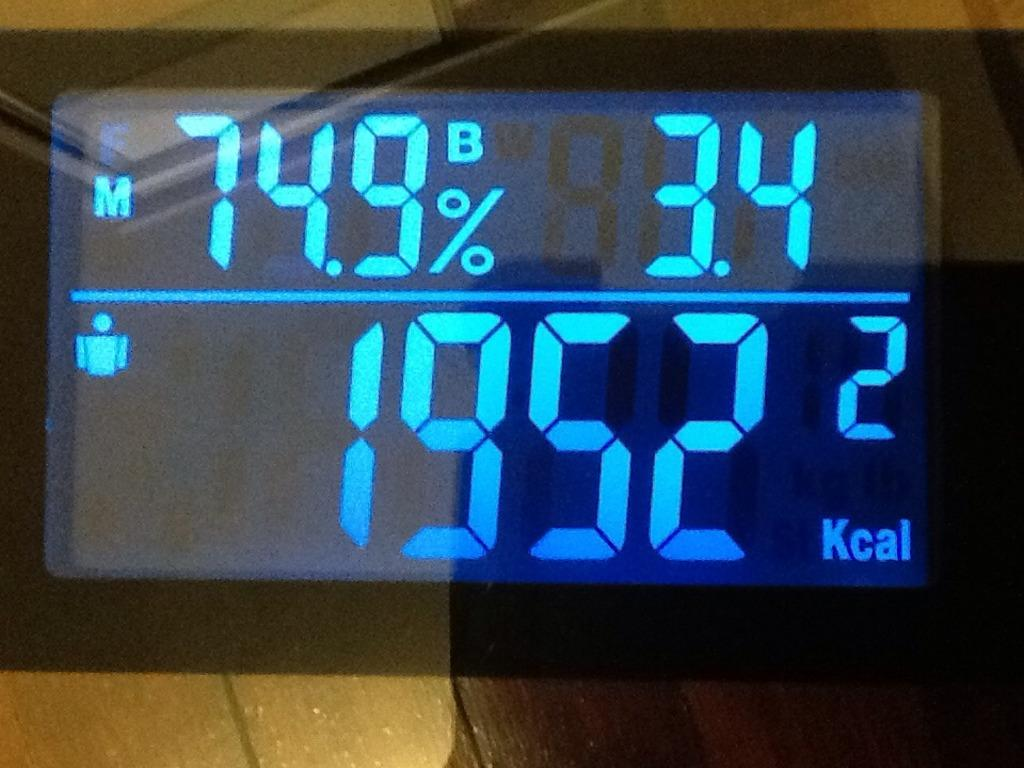<image>
Write a terse but informative summary of the picture. A digital display shows just under 2000 Kcals. 